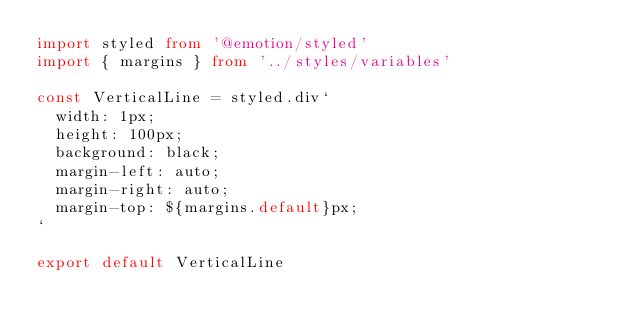Convert code to text. <code><loc_0><loc_0><loc_500><loc_500><_TypeScript_>import styled from '@emotion/styled'
import { margins } from '../styles/variables'

const VerticalLine = styled.div`
  width: 1px;
  height: 100px;
  background: black;
  margin-left: auto;
  margin-right: auto;
  margin-top: ${margins.default}px;
`

export default VerticalLine
</code> 